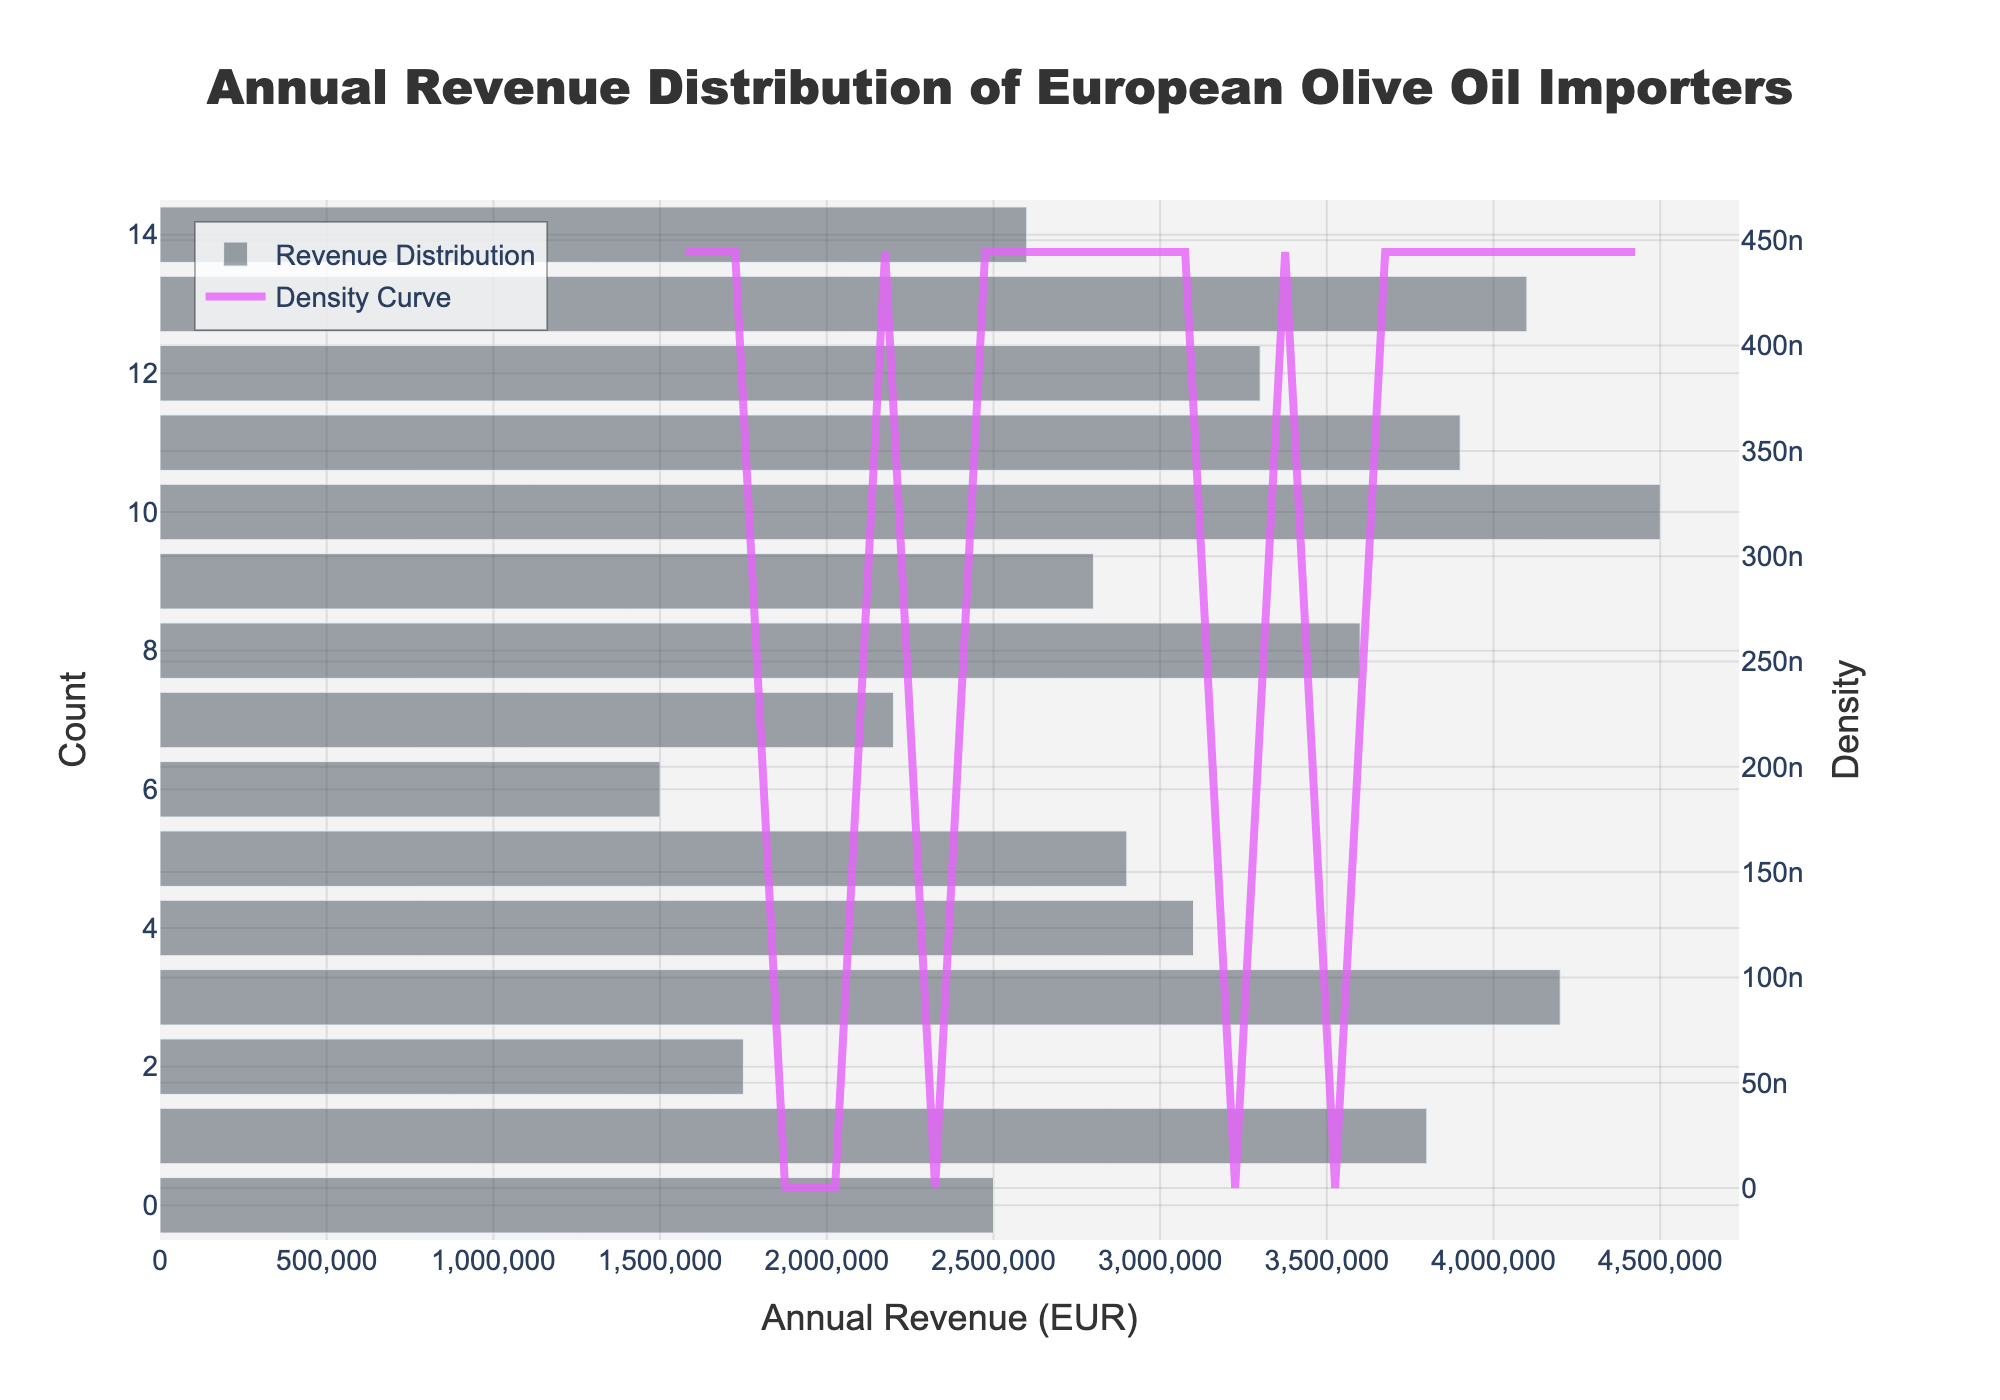What is the title of the plot? The title of the plot is displayed at the top-center and is in larger bold font compared to other text elements.
Answer: Annual Revenue Distribution of European Olive Oil Importers What is the x-axis labeled as? The x-axis label is provided below the horizontal axis and indicates what the x-axis represents. It often includes a textual description.
Answer: Annual Revenue (EUR) How many companies have annual revenues in the 2 to 3 million EUR range? To determine this, observe the histogram bars. Count the bars within the 2 to 3 million EUR range on the x-axis and sum the heights.
Answer: 5 companies Which company appears to have the highest annual revenue? To find this, look at the rightmost bar of the histogram, which represents the highest value on the x-axis.
Answer: Italian Olive Excellence SpA How is the density curve colored? The density curve color is distinctive from the bars to clearly differentiate it. Look for a curve color description in the chart's legend or identify visibly from the curve's color.
Answer: Purple What is the approximate peak density value on the KDE curve, and where does it occur? The KDE peak is the highest point on the density curve. Find the y-value of the KDE curve at this peak and determine its corresponding x-position.
Answer: Peak density about 0.000006, occurs around 2.7 million EUR How does the distribution of annual revenues skew in the histogram? Determine skewness by observing which side of the histogram has longer tails or where the bulk of the data is concentrated.
Answer: Right-skewed What is the range of annual revenues covered in the distribution? Find the minimum and maximum x-values displayed on the histogram, representing the smallest and largest revenues.
Answer: 1.5 million EUR to 4.5 million EUR Compare the density of companies with annual revenues of approximately 2 million EUR to those with 4 million EUR. Check the KDE curve to see the height at these two specific x-values (2 million EUR and 4 million EUR). Compare their y-values which indicate the density.
Answer: Density higher at 2 million EUR Between which two consecutive bins in the histogram does the largest drop in count occur? Examine the height difference between consecutive histogram bars and identify the pair with the greatest decrease.
Answer: Between 1.75 and 2 million EUR What insight can be drawn about the annual revenue distributions across the European olive oil importers? Analyze the histogram and KDE curve to summarize the general pattern, including skewness, concentration, and range. Discuss how most companies' revenues cluster and any noticeable features.
Answer: Most companies earn between 2-3 million EUR, with revenues being right-skewed 